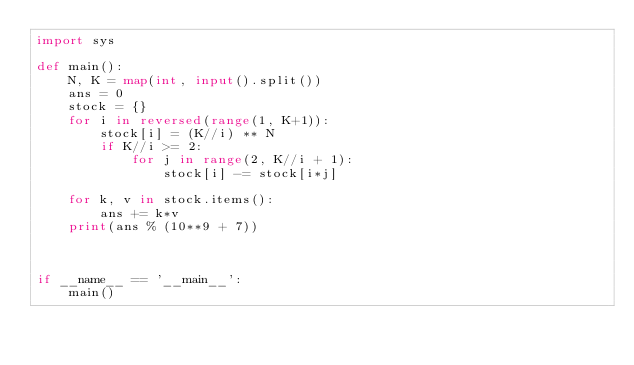Convert code to text. <code><loc_0><loc_0><loc_500><loc_500><_Python_>import sys

def main():
    N, K = map(int, input().split())
    ans = 0
    stock = {}
    for i in reversed(range(1, K+1)):
        stock[i] = (K//i) ** N
        if K//i >= 2:
            for j in range(2, K//i + 1):
                stock[i] -= stock[i*j]
                
    for k, v in stock.items():
        ans += k*v
    print(ans % (10**9 + 7))
    
        
    
if __name__ == '__main__':
    main()</code> 